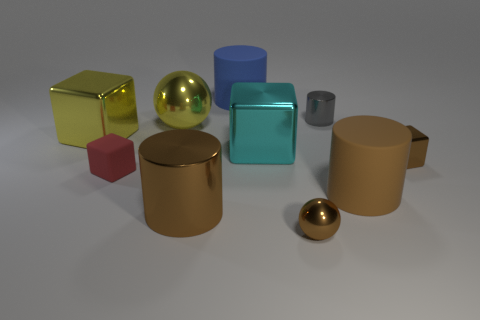Subtract 1 blocks. How many blocks are left? 3 Subtract all cyan cylinders. Subtract all yellow spheres. How many cylinders are left? 4 Subtract all blocks. How many objects are left? 6 Subtract all small green cylinders. Subtract all brown cubes. How many objects are left? 9 Add 1 large metal blocks. How many large metal blocks are left? 3 Add 8 cyan cubes. How many cyan cubes exist? 9 Subtract 1 brown blocks. How many objects are left? 9 